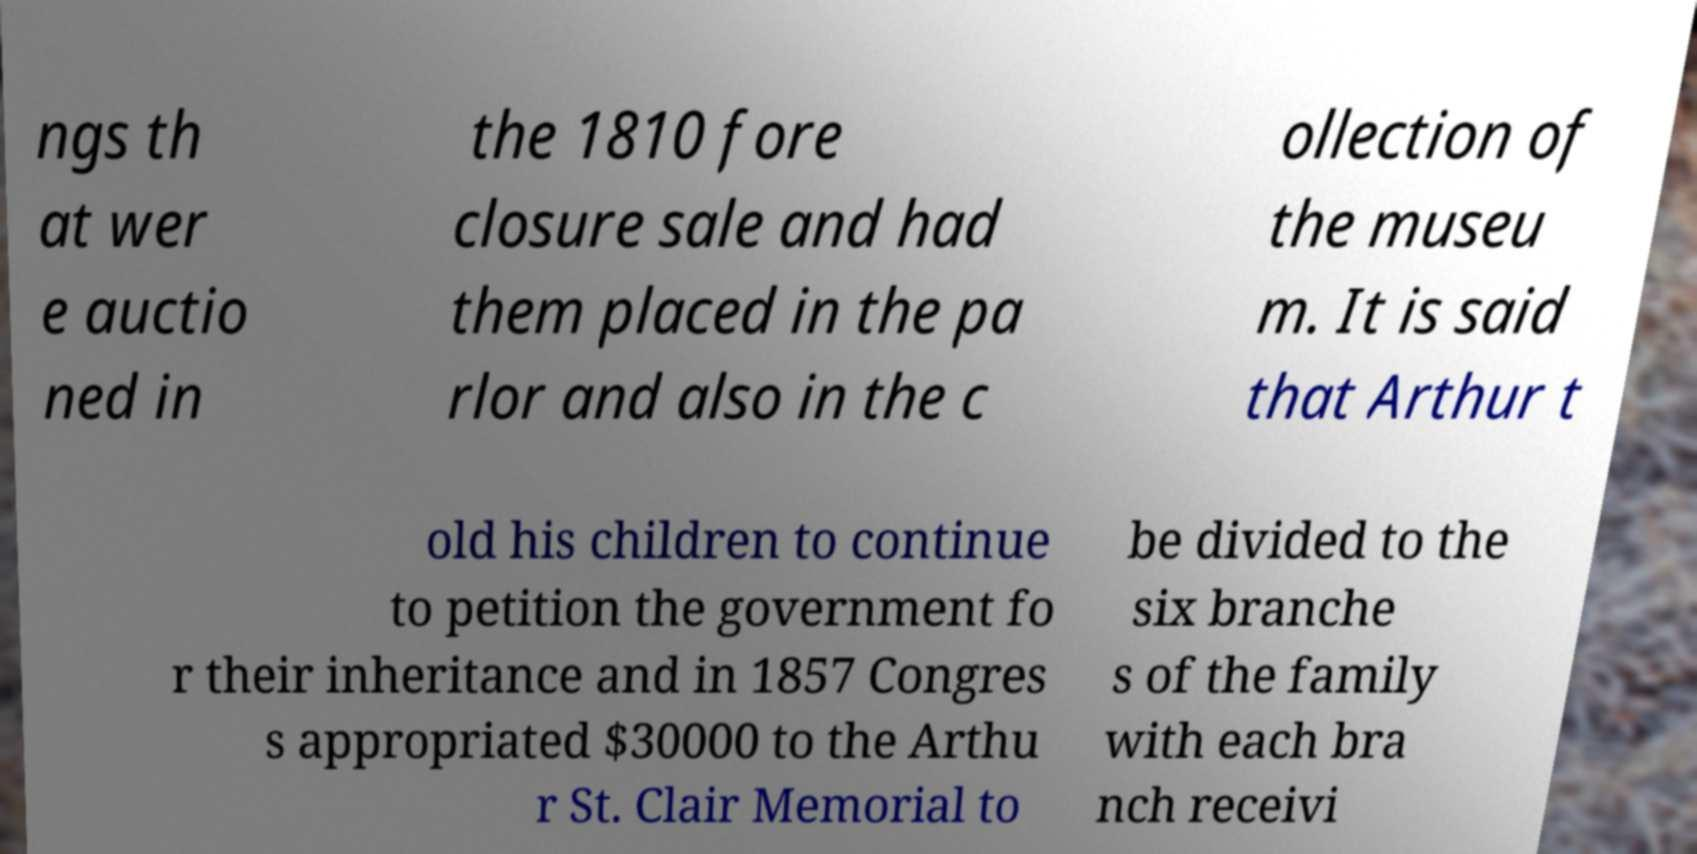Could you extract and type out the text from this image? ngs th at wer e auctio ned in the 1810 fore closure sale and had them placed in the pa rlor and also in the c ollection of the museu m. It is said that Arthur t old his children to continue to petition the government fo r their inheritance and in 1857 Congres s appropriated $30000 to the Arthu r St. Clair Memorial to be divided to the six branche s of the family with each bra nch receivi 